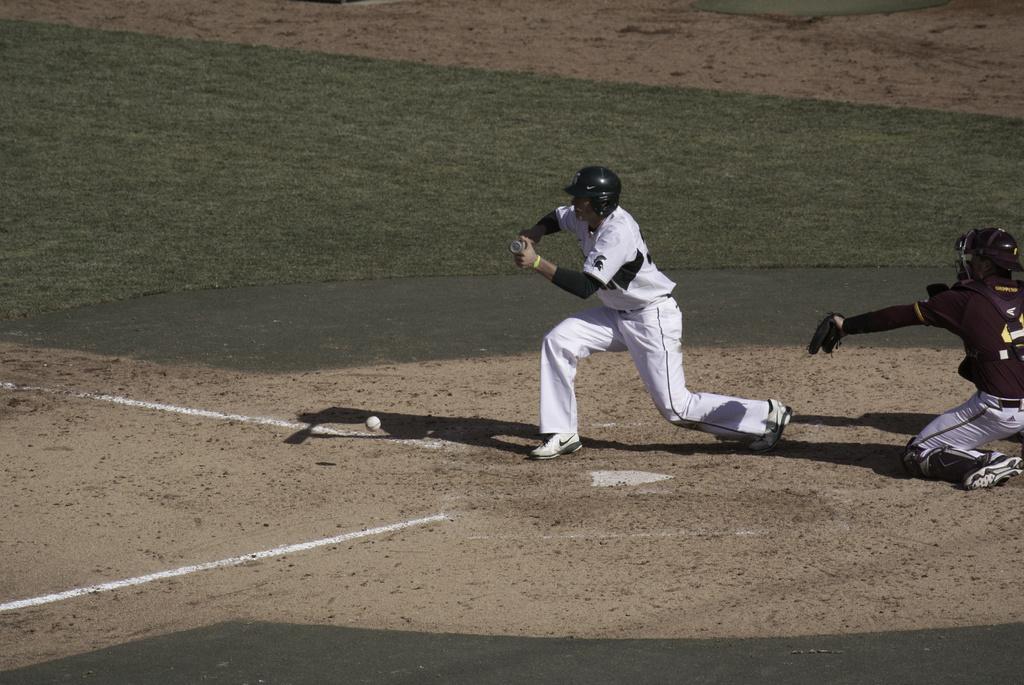Please provide a concise description of this image. In this image there are two player on the field. Here there is a ball. In the middle the player is holding a bat wearing white dress. In the left there is a player wearing maroon t-shirt. On the ground there are grasses over here. 